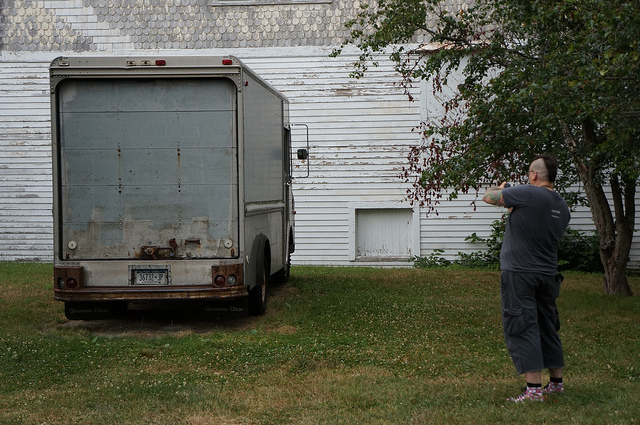Identify the text contained in this image. 35737 